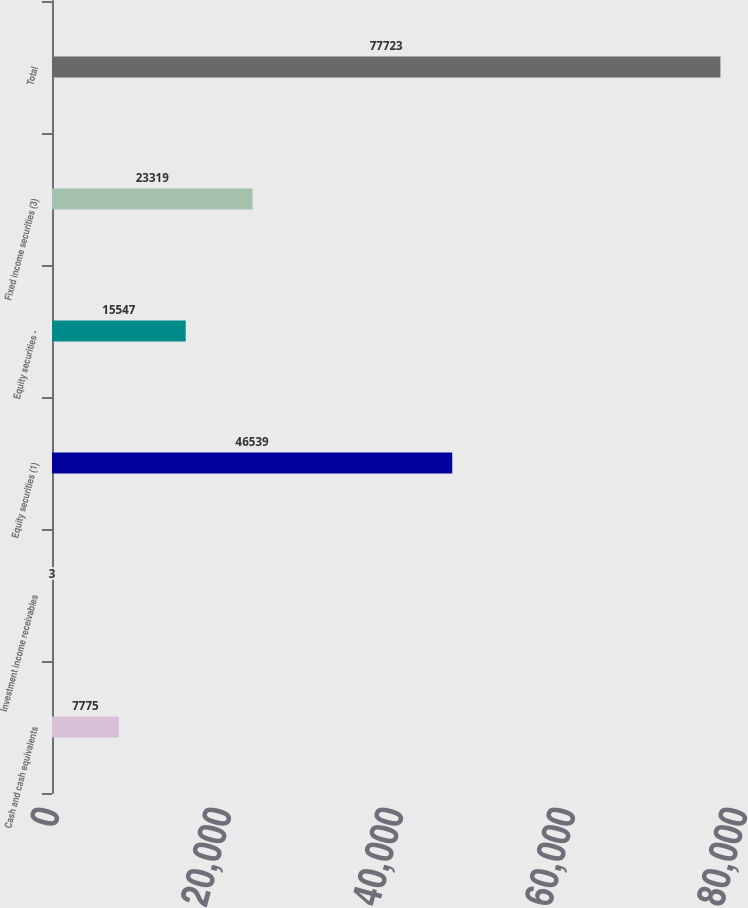<chart> <loc_0><loc_0><loc_500><loc_500><bar_chart><fcel>Cash and cash equivalents<fcel>Investment income receivables<fcel>Equity securities (1)<fcel>Equity securities -<fcel>Fixed income securities (3)<fcel>Total<nl><fcel>7775<fcel>3<fcel>46539<fcel>15547<fcel>23319<fcel>77723<nl></chart> 